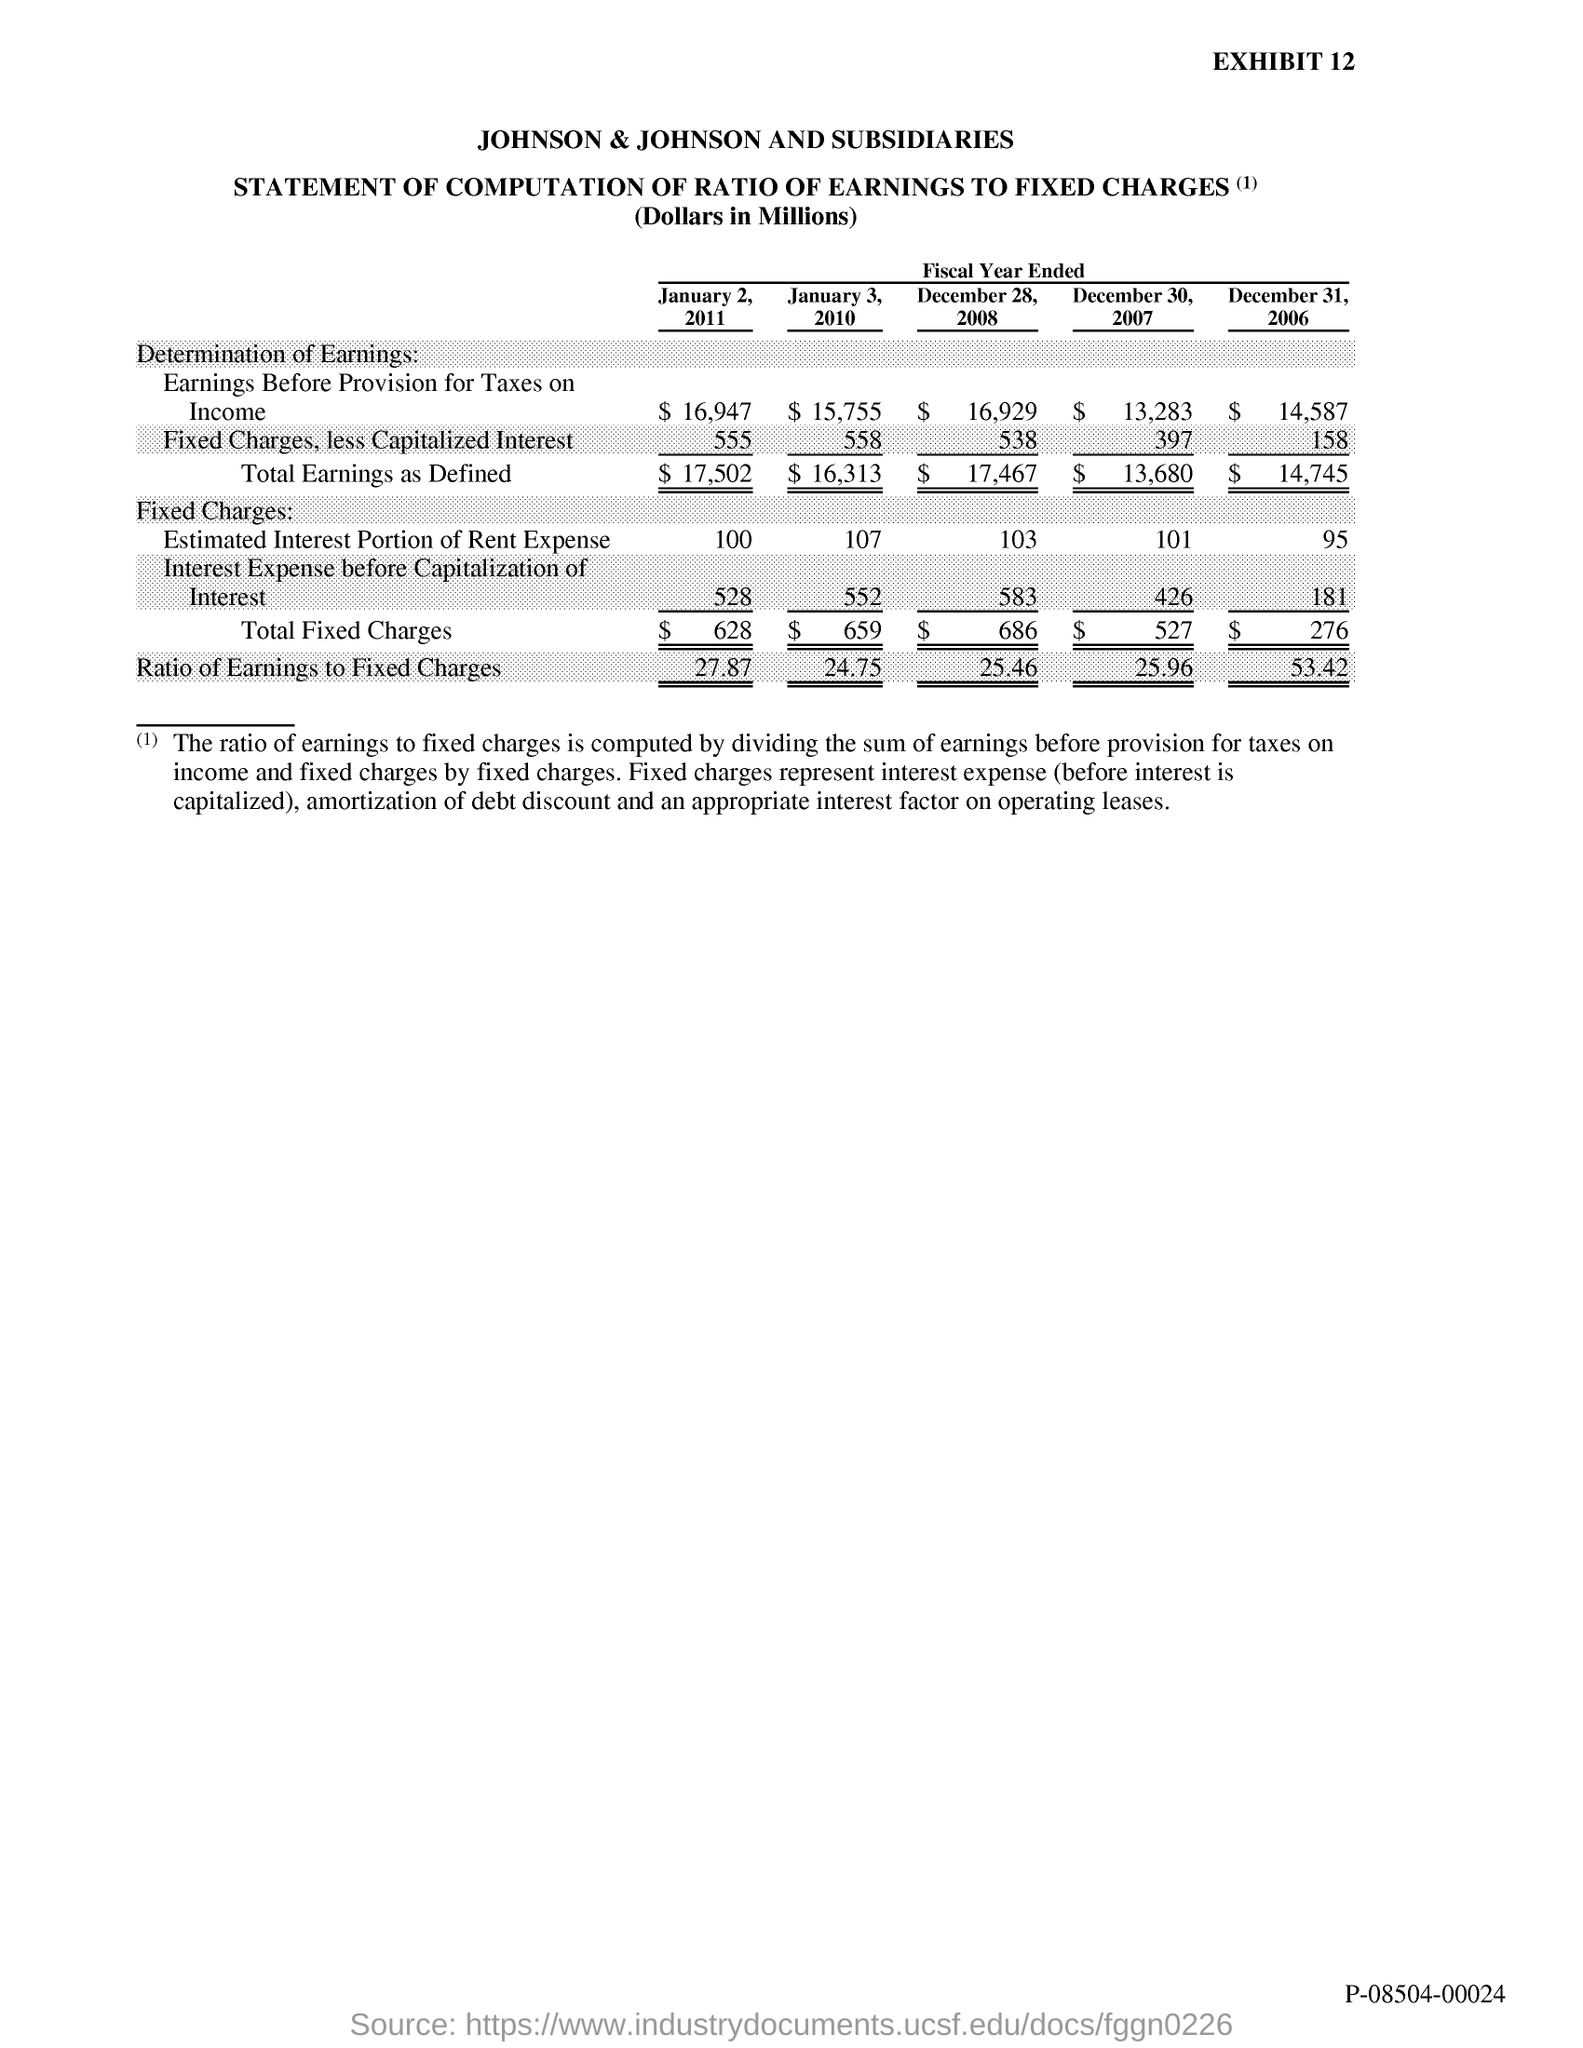What is the Exhibit number?
Offer a terse response. 12. What is the first title in the document?
Your answer should be very brief. Johnson & Johnson and subsidiaries. 